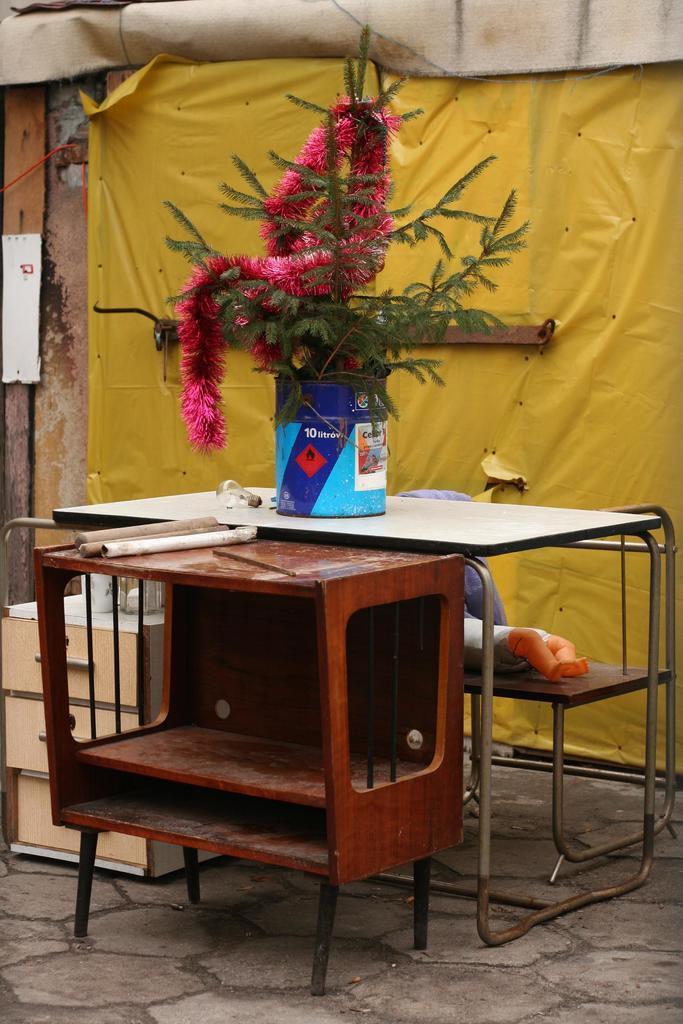In one or two sentences, can you explain what this image depicts? In the image I can see a table on which there is a plant, doll and behind there is a yellow color cover to the wall. 